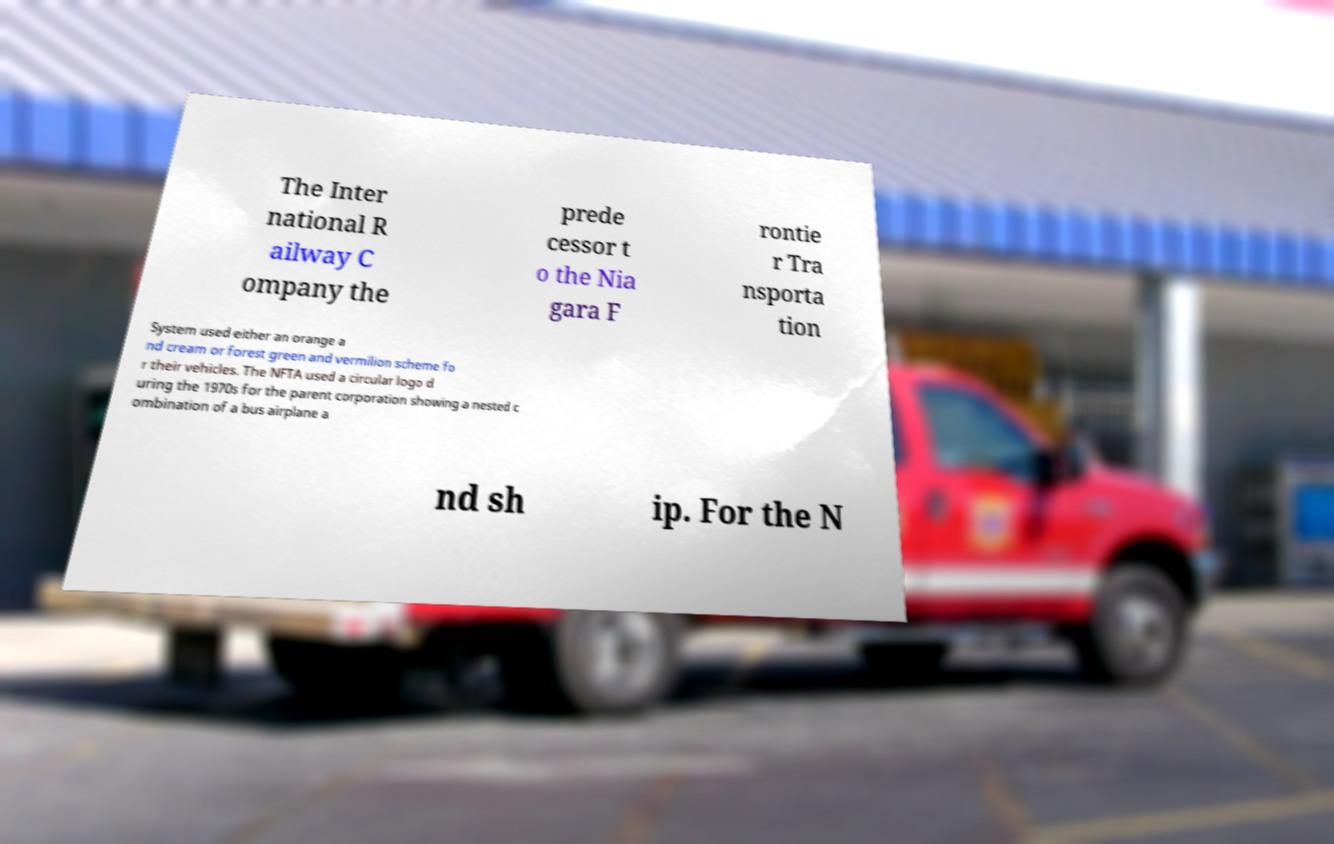There's text embedded in this image that I need extracted. Can you transcribe it verbatim? The Inter national R ailway C ompany the prede cessor t o the Nia gara F rontie r Tra nsporta tion System used either an orange a nd cream or forest green and vermilion scheme fo r their vehicles. The NFTA used a circular logo d uring the 1970s for the parent corporation showing a nested c ombination of a bus airplane a nd sh ip. For the N 